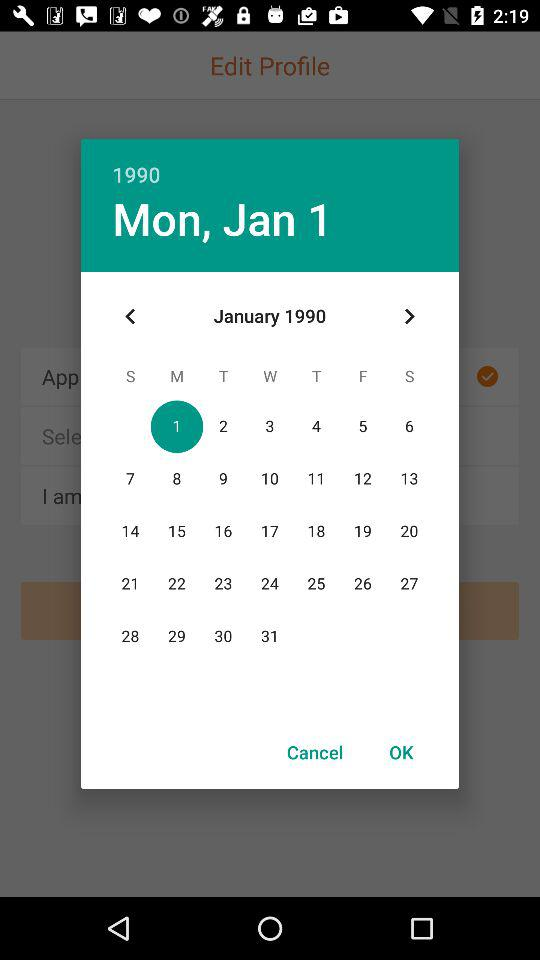Which is the selected date? The selected date is Monday, January 1, 1990. 